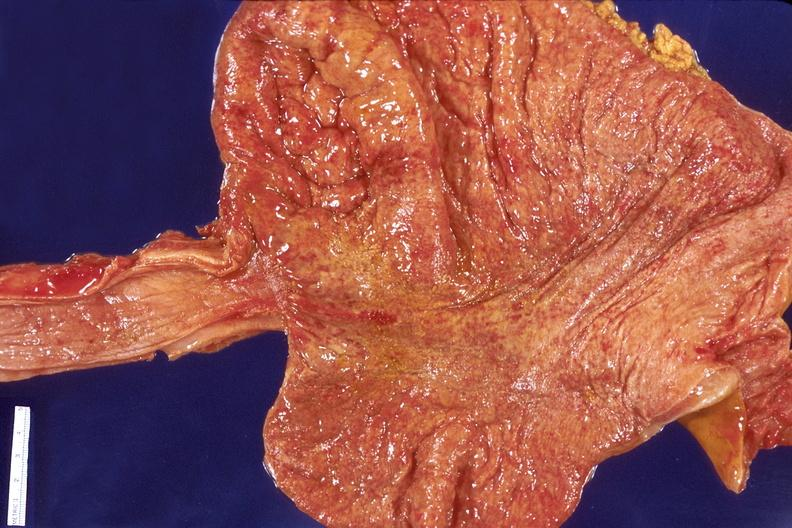where does this belong to?
Answer the question using a single word or phrase. Gastrointestinal system 